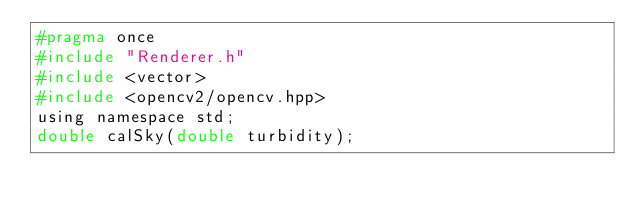Convert code to text. <code><loc_0><loc_0><loc_500><loc_500><_C_>#pragma once
#include "Renderer.h"
#include <vector>
#include <opencv2/opencv.hpp>
using namespace std;
double calSky(double turbidity);
</code> 